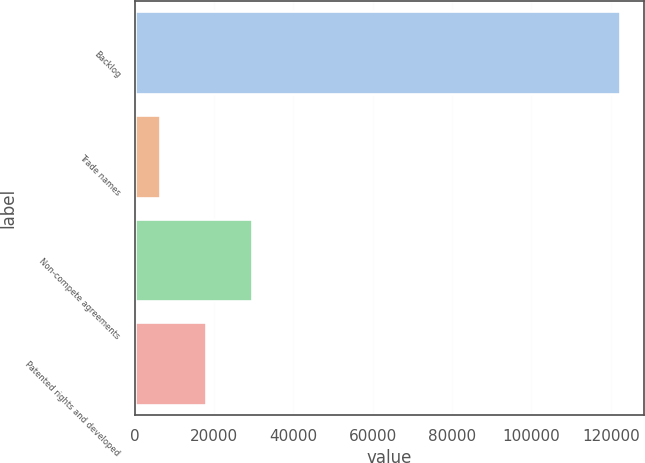Convert chart to OTSL. <chart><loc_0><loc_0><loc_500><loc_500><bar_chart><fcel>Backlog<fcel>Trade names<fcel>Non-compete agreements<fcel>Patented rights and developed<nl><fcel>122265<fcel>6278<fcel>29475.4<fcel>17876.7<nl></chart> 